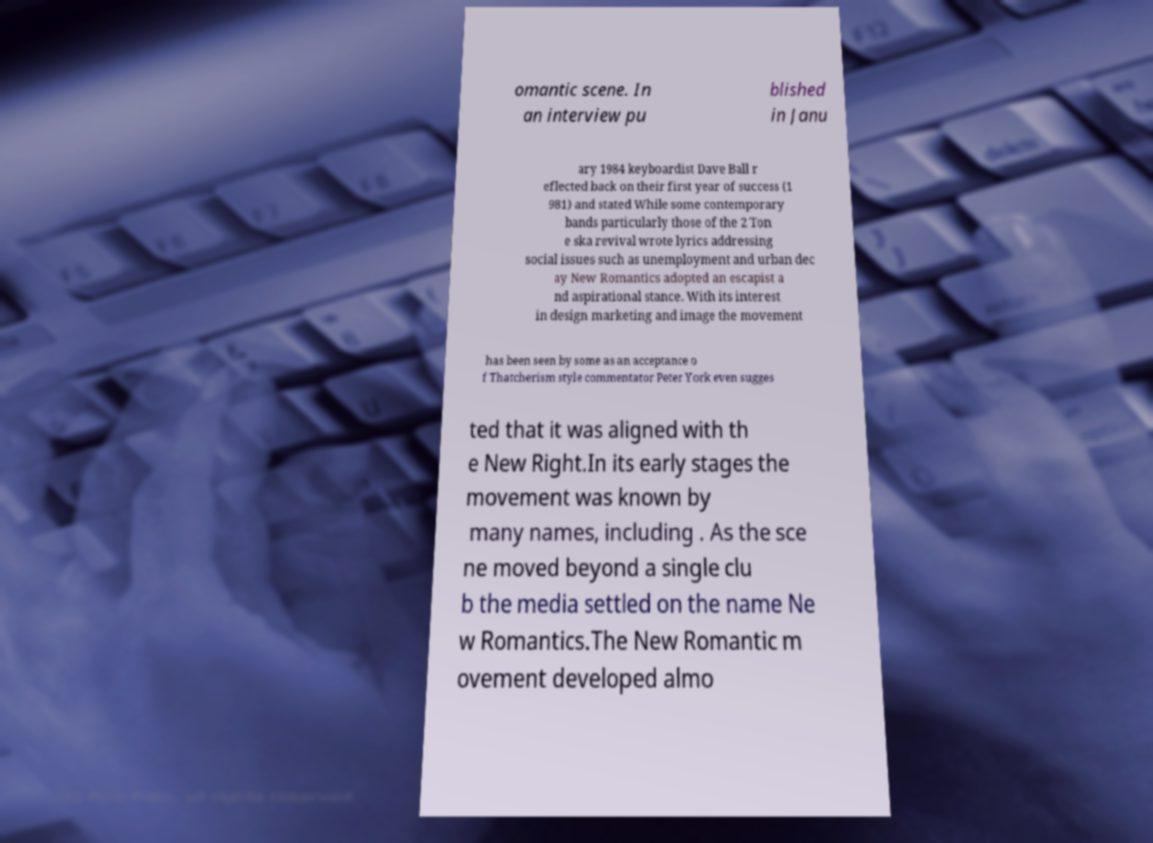Please read and relay the text visible in this image. What does it say? omantic scene. In an interview pu blished in Janu ary 1984 keyboardist Dave Ball r eflected back on their first year of success (1 981) and stated While some contemporary bands particularly those of the 2 Ton e ska revival wrote lyrics addressing social issues such as unemployment and urban dec ay New Romantics adopted an escapist a nd aspirational stance. With its interest in design marketing and image the movement has been seen by some as an acceptance o f Thatcherism style commentator Peter York even sugges ted that it was aligned with th e New Right.In its early stages the movement was known by many names, including . As the sce ne moved beyond a single clu b the media settled on the name Ne w Romantics.The New Romantic m ovement developed almo 